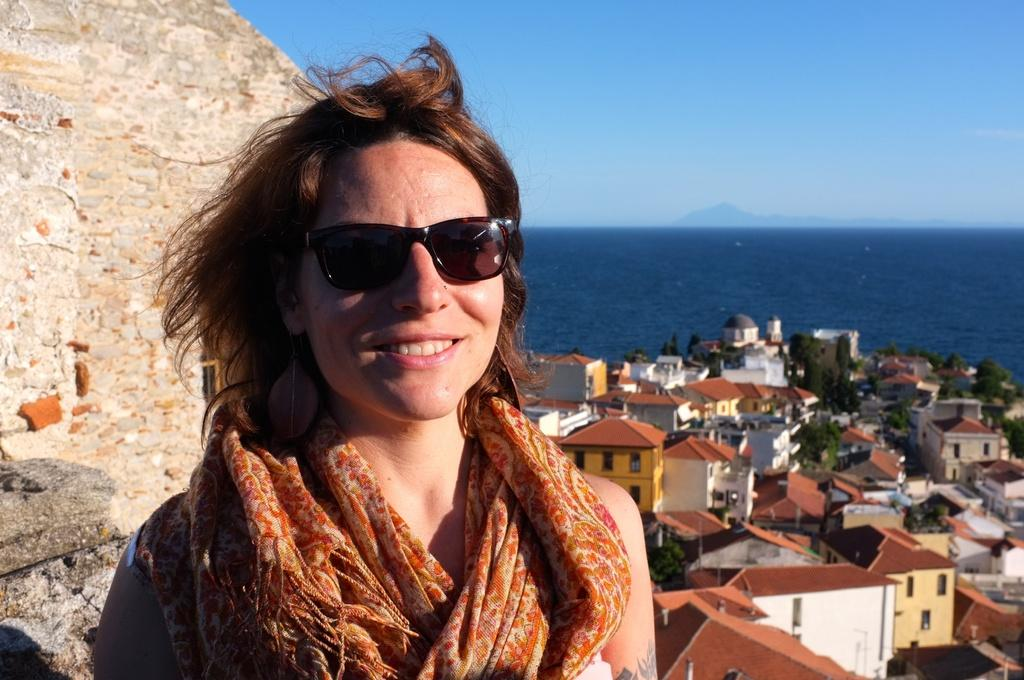Who is present in the image? There is a woman in the image. What is the woman wearing on her head? The woman is wearing a scarf. What is the woman wearing on her face? The woman is wearing goggles. What can be seen in the background of the image? There is water, buildings, trees, a wall, and the sky visible in the background of the image. What type of wrench is the woman using to transport the girl in the image? There is no wrench or girl present in the image. 